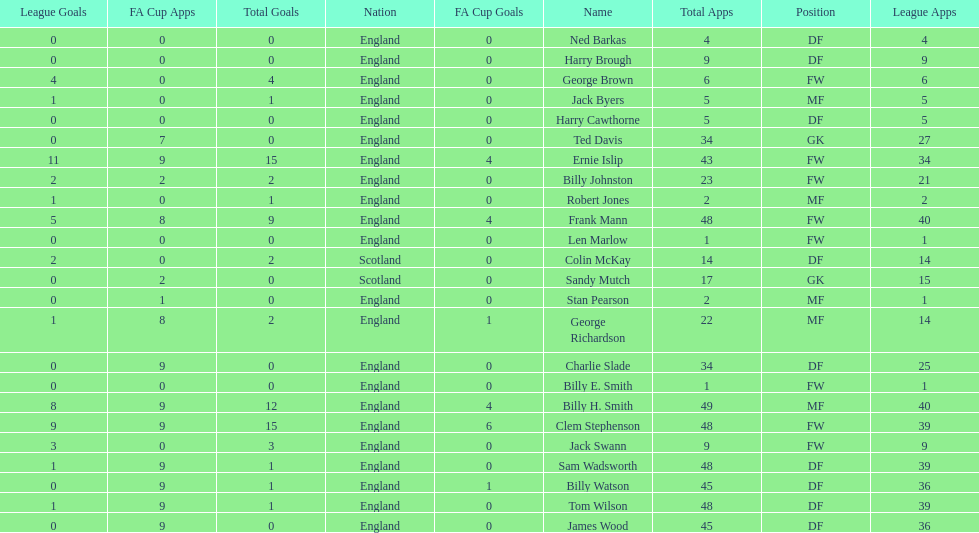How many players are fws? 8. 